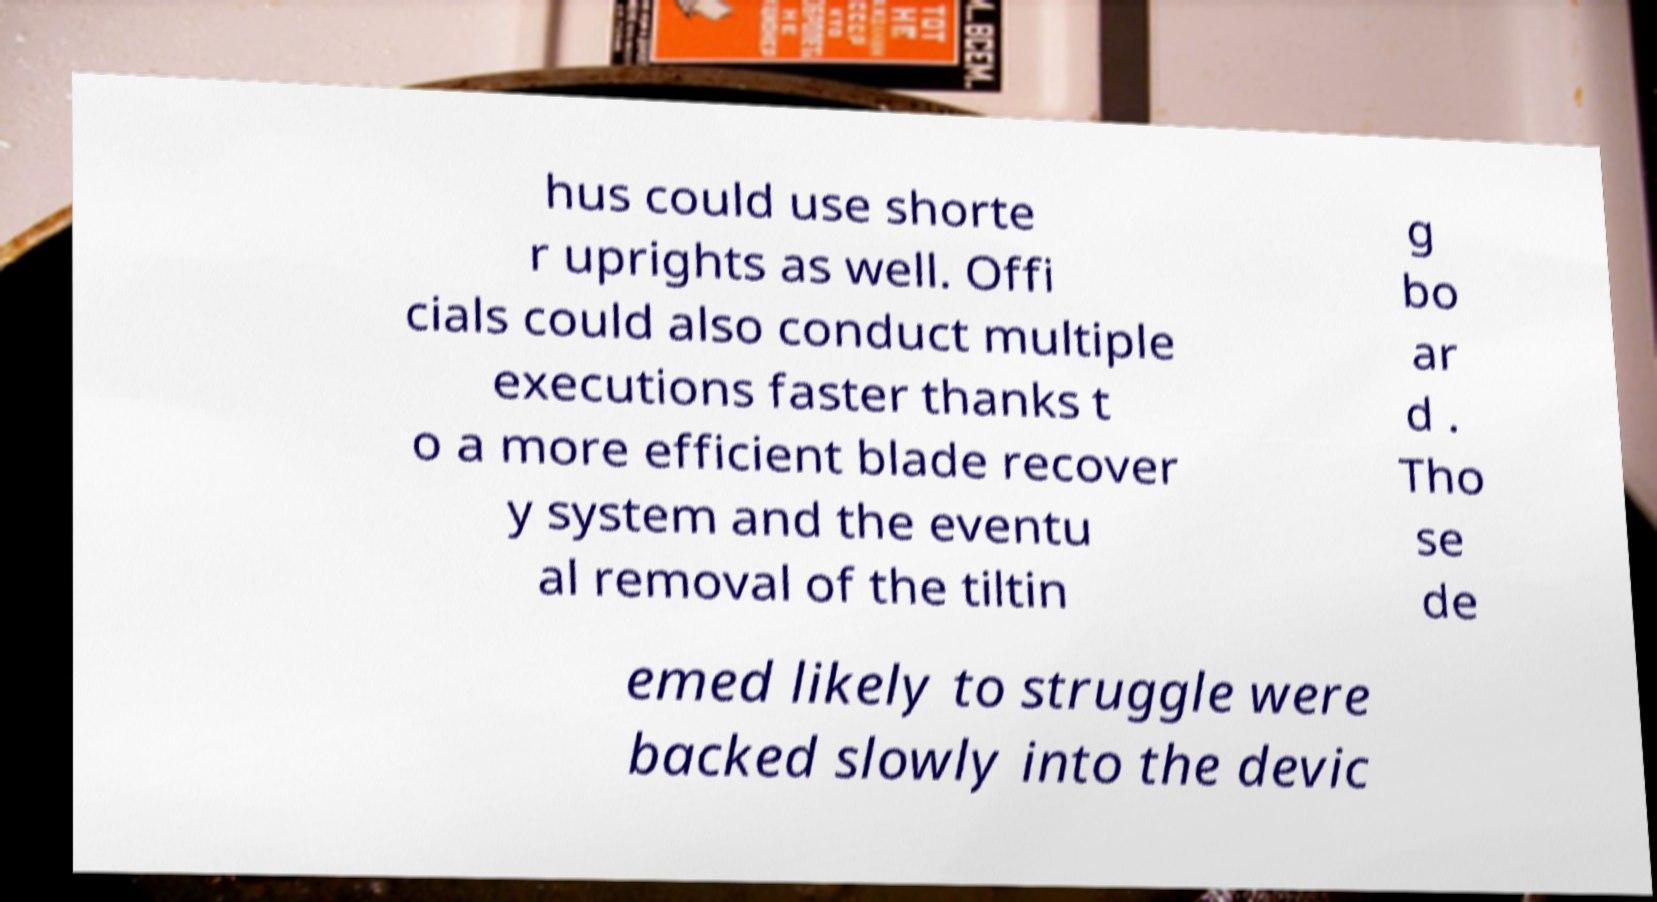For documentation purposes, I need the text within this image transcribed. Could you provide that? hus could use shorte r uprights as well. Offi cials could also conduct multiple executions faster thanks t o a more efficient blade recover y system and the eventu al removal of the tiltin g bo ar d . Tho se de emed likely to struggle were backed slowly into the devic 